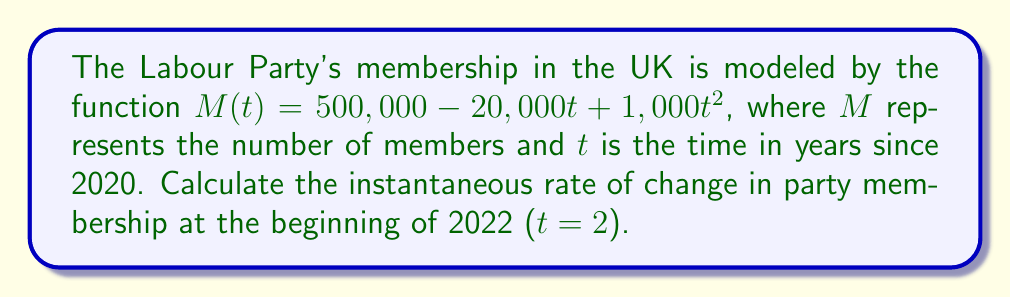Can you solve this math problem? To find the instantaneous rate of change, we need to calculate the derivative of the function $M(t)$ and evaluate it at $t = 2$.

Step 1: Find the derivative of $M(t)$.
$M(t) = 500,000 - 20,000t + 1,000t^2$
$M'(t) = -20,000 + 2,000t$

Step 2: Evaluate $M'(t)$ at $t = 2$.
$M'(2) = -20,000 + 2,000(2)$
$M'(2) = -20,000 + 4,000$
$M'(2) = -16,000$

Step 3: Interpret the result.
The instantaneous rate of change at $t = 2$ (beginning of 2022) is -16,000 members per year. The negative value indicates that the party is losing members at that point in time.
Answer: $-16,000$ members per year 